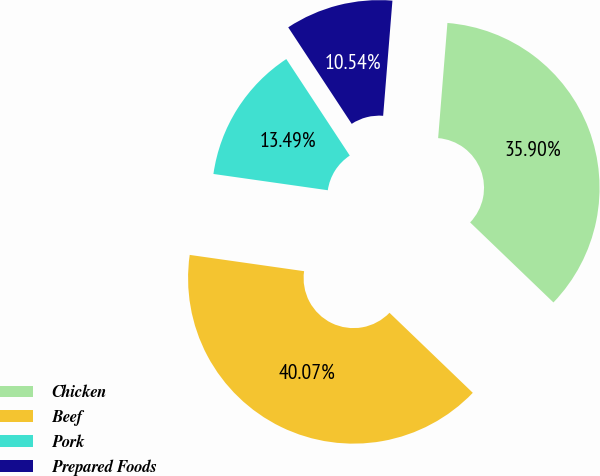Convert chart. <chart><loc_0><loc_0><loc_500><loc_500><pie_chart><fcel>Chicken<fcel>Beef<fcel>Pork<fcel>Prepared Foods<nl><fcel>35.9%<fcel>40.07%<fcel>13.49%<fcel>10.54%<nl></chart> 